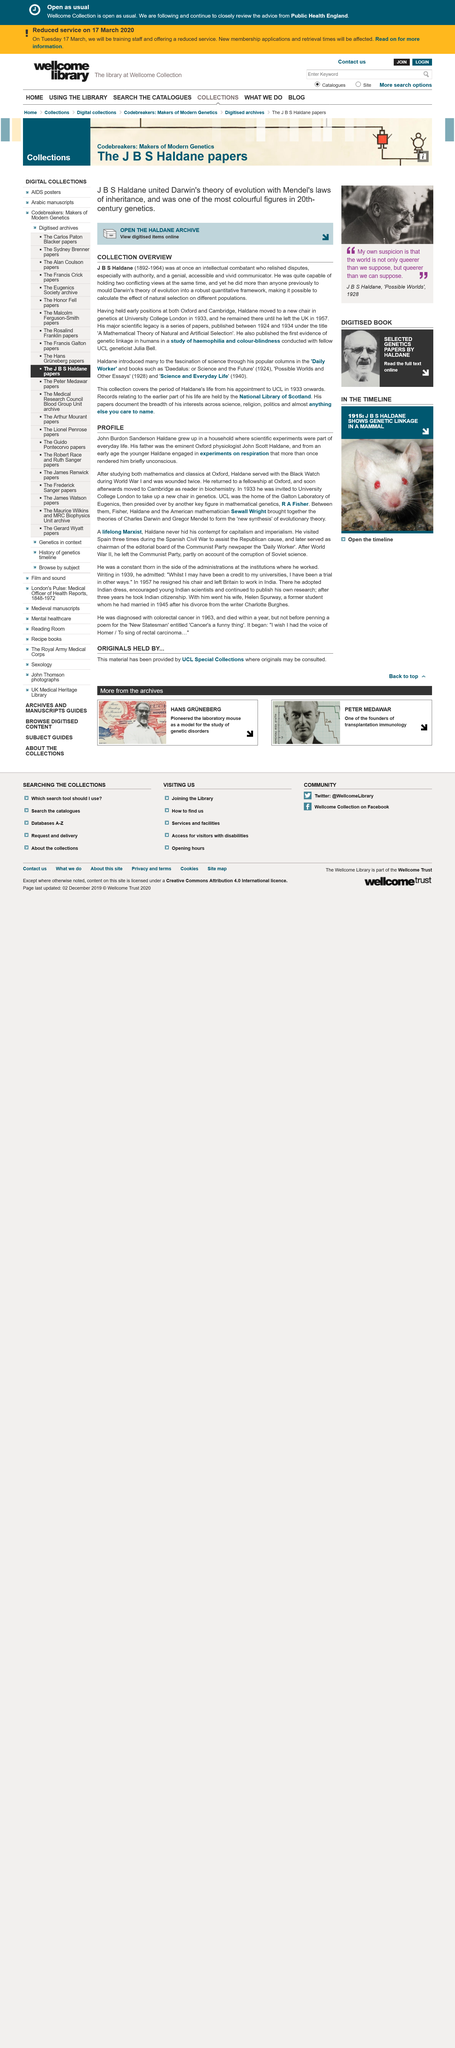Identify some key points in this picture. Haldane helped to create a new synthesis of evolutionary theory. John engaged in experiments on respiration, resulting in his being rendered briefly unconscious multiple times. Haldane conducted experiments on respiration from an early age, which included investigating the process of breathing and its effects on living organisms. 